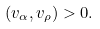Convert formula to latex. <formula><loc_0><loc_0><loc_500><loc_500>( v _ { \alpha } , v _ { \rho } ) > 0 .</formula> 